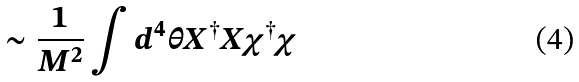Convert formula to latex. <formula><loc_0><loc_0><loc_500><loc_500>\sim \frac { 1 } { M ^ { 2 } } \int d ^ { 4 } \theta X ^ { \dagger } X \chi ^ { \dagger } \chi</formula> 